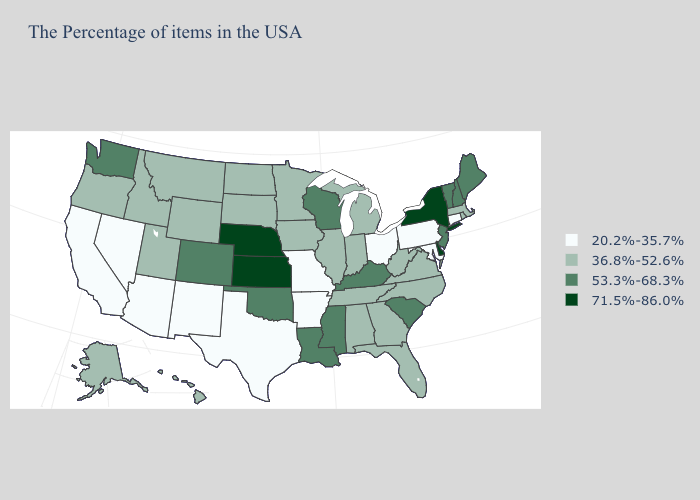Does Connecticut have a lower value than North Carolina?
Short answer required. Yes. What is the value of Idaho?
Concise answer only. 36.8%-52.6%. Among the states that border Idaho , which have the highest value?
Keep it brief. Washington. Does Rhode Island have the highest value in the Northeast?
Write a very short answer. No. Is the legend a continuous bar?
Be succinct. No. What is the value of Nebraska?
Concise answer only. 71.5%-86.0%. What is the value of Nevada?
Short answer required. 20.2%-35.7%. What is the highest value in states that border New Mexico?
Write a very short answer. 53.3%-68.3%. Name the states that have a value in the range 71.5%-86.0%?
Give a very brief answer. New York, Delaware, Kansas, Nebraska. Name the states that have a value in the range 71.5%-86.0%?
Concise answer only. New York, Delaware, Kansas, Nebraska. Does New York have the highest value in the Northeast?
Answer briefly. Yes. Name the states that have a value in the range 36.8%-52.6%?
Be succinct. Massachusetts, Rhode Island, Virginia, North Carolina, West Virginia, Florida, Georgia, Michigan, Indiana, Alabama, Tennessee, Illinois, Minnesota, Iowa, South Dakota, North Dakota, Wyoming, Utah, Montana, Idaho, Oregon, Alaska, Hawaii. What is the lowest value in the West?
Write a very short answer. 20.2%-35.7%. What is the highest value in the USA?
Answer briefly. 71.5%-86.0%. 